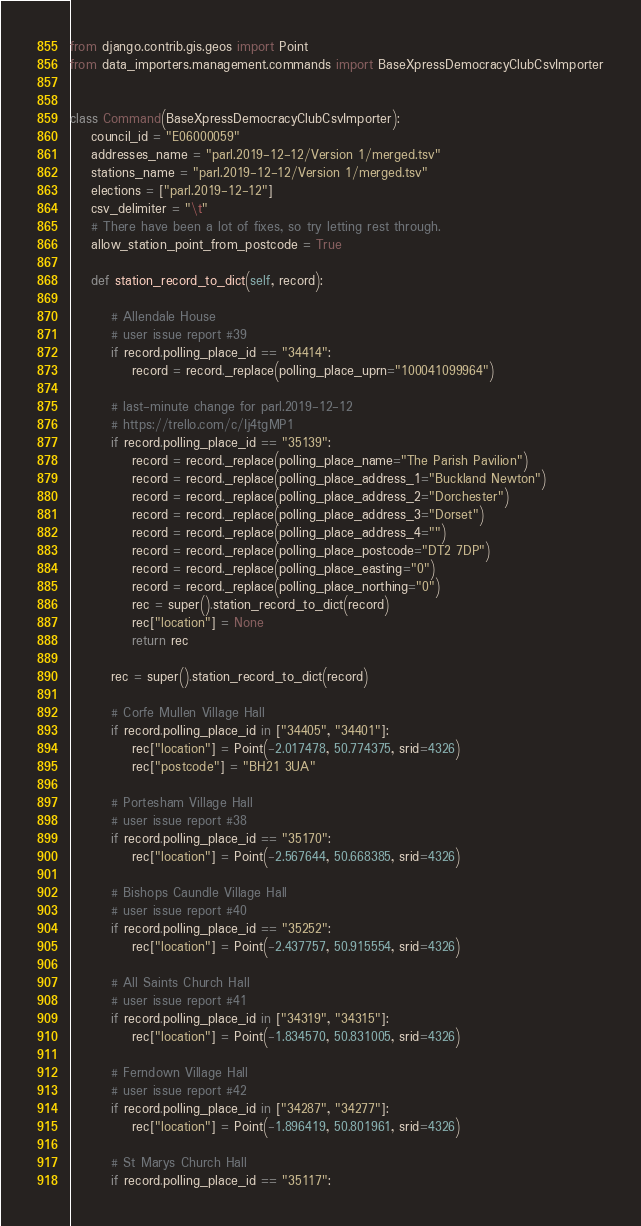<code> <loc_0><loc_0><loc_500><loc_500><_Python_>from django.contrib.gis.geos import Point
from data_importers.management.commands import BaseXpressDemocracyClubCsvImporter


class Command(BaseXpressDemocracyClubCsvImporter):
    council_id = "E06000059"
    addresses_name = "parl.2019-12-12/Version 1/merged.tsv"
    stations_name = "parl.2019-12-12/Version 1/merged.tsv"
    elections = ["parl.2019-12-12"]
    csv_delimiter = "\t"
    # There have been a lot of fixes, so try letting rest through.
    allow_station_point_from_postcode = True

    def station_record_to_dict(self, record):

        # Allendale House
        # user issue report #39
        if record.polling_place_id == "34414":
            record = record._replace(polling_place_uprn="100041099964")

        # last-minute change for parl.2019-12-12
        # https://trello.com/c/Ij4tgMP1
        if record.polling_place_id == "35139":
            record = record._replace(polling_place_name="The Parish Pavilion")
            record = record._replace(polling_place_address_1="Buckland Newton")
            record = record._replace(polling_place_address_2="Dorchester")
            record = record._replace(polling_place_address_3="Dorset")
            record = record._replace(polling_place_address_4="")
            record = record._replace(polling_place_postcode="DT2 7DP")
            record = record._replace(polling_place_easting="0")
            record = record._replace(polling_place_northing="0")
            rec = super().station_record_to_dict(record)
            rec["location"] = None
            return rec

        rec = super().station_record_to_dict(record)

        # Corfe Mullen Village Hall
        if record.polling_place_id in ["34405", "34401"]:
            rec["location"] = Point(-2.017478, 50.774375, srid=4326)
            rec["postcode"] = "BH21 3UA"

        # Portesham Village Hall
        # user issue report #38
        if record.polling_place_id == "35170":
            rec["location"] = Point(-2.567644, 50.668385, srid=4326)

        # Bishops Caundle Village Hall
        # user issue report #40
        if record.polling_place_id == "35252":
            rec["location"] = Point(-2.437757, 50.915554, srid=4326)

        # All Saints Church Hall
        # user issue report #41
        if record.polling_place_id in ["34319", "34315"]:
            rec["location"] = Point(-1.834570, 50.831005, srid=4326)

        # Ferndown Village Hall
        # user issue report #42
        if record.polling_place_id in ["34287", "34277"]:
            rec["location"] = Point(-1.896419, 50.801961, srid=4326)

        # St Marys Church Hall
        if record.polling_place_id == "35117":</code> 